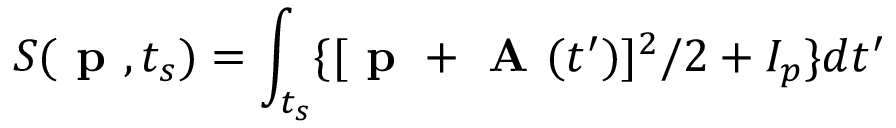Convert formula to latex. <formula><loc_0><loc_0><loc_500><loc_500>S ( p , t _ { s } ) = \int _ { t _ { s } } \{ { [ p + A ( t ^ { \prime } } ) ] ^ { 2 } / 2 + I _ { p } \} d t ^ { \prime }</formula> 